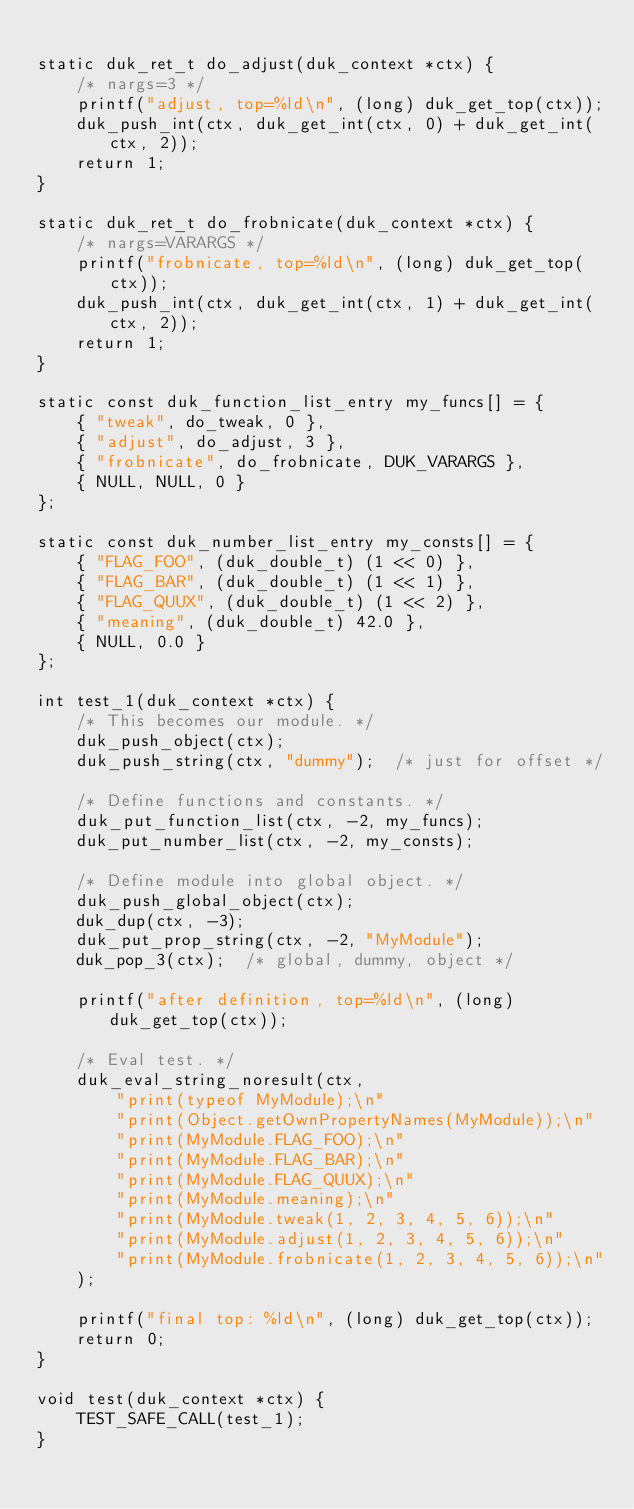<code> <loc_0><loc_0><loc_500><loc_500><_C_>
static duk_ret_t do_adjust(duk_context *ctx) {
	/* nargs=3 */
	printf("adjust, top=%ld\n", (long) duk_get_top(ctx));
	duk_push_int(ctx, duk_get_int(ctx, 0) + duk_get_int(ctx, 2));
	return 1;
}

static duk_ret_t do_frobnicate(duk_context *ctx) {
	/* nargs=VARARGS */
	printf("frobnicate, top=%ld\n", (long) duk_get_top(ctx));
	duk_push_int(ctx, duk_get_int(ctx, 1) + duk_get_int(ctx, 2));
	return 1;
}

static const duk_function_list_entry my_funcs[] = {
	{ "tweak", do_tweak, 0 },
	{ "adjust", do_adjust, 3 },
	{ "frobnicate", do_frobnicate, DUK_VARARGS },
	{ NULL, NULL, 0 }
};

static const duk_number_list_entry my_consts[] = {
	{ "FLAG_FOO", (duk_double_t) (1 << 0) },
	{ "FLAG_BAR", (duk_double_t) (1 << 1) },
	{ "FLAG_QUUX", (duk_double_t) (1 << 2) },
	{ "meaning", (duk_double_t) 42.0 },
	{ NULL, 0.0 }
};

int test_1(duk_context *ctx) {
	/* This becomes our module. */
	duk_push_object(ctx);
	duk_push_string(ctx, "dummy");  /* just for offset */

	/* Define functions and constants. */
	duk_put_function_list(ctx, -2, my_funcs);
	duk_put_number_list(ctx, -2, my_consts);

	/* Define module into global object. */
	duk_push_global_object(ctx);
	duk_dup(ctx, -3);
	duk_put_prop_string(ctx, -2, "MyModule");
	duk_pop_3(ctx);  /* global, dummy, object */

	printf("after definition, top=%ld\n", (long) duk_get_top(ctx));

	/* Eval test. */
	duk_eval_string_noresult(ctx,
	    "print(typeof MyModule);\n"
	    "print(Object.getOwnPropertyNames(MyModule));\n"
	    "print(MyModule.FLAG_FOO);\n"
	    "print(MyModule.FLAG_BAR);\n"
	    "print(MyModule.FLAG_QUUX);\n"
	    "print(MyModule.meaning);\n"
	    "print(MyModule.tweak(1, 2, 3, 4, 5, 6));\n"
	    "print(MyModule.adjust(1, 2, 3, 4, 5, 6));\n"
	    "print(MyModule.frobnicate(1, 2, 3, 4, 5, 6));\n"
	);

	printf("final top: %ld\n", (long) duk_get_top(ctx));
	return 0;
}

void test(duk_context *ctx) {
	TEST_SAFE_CALL(test_1);
}
</code> 